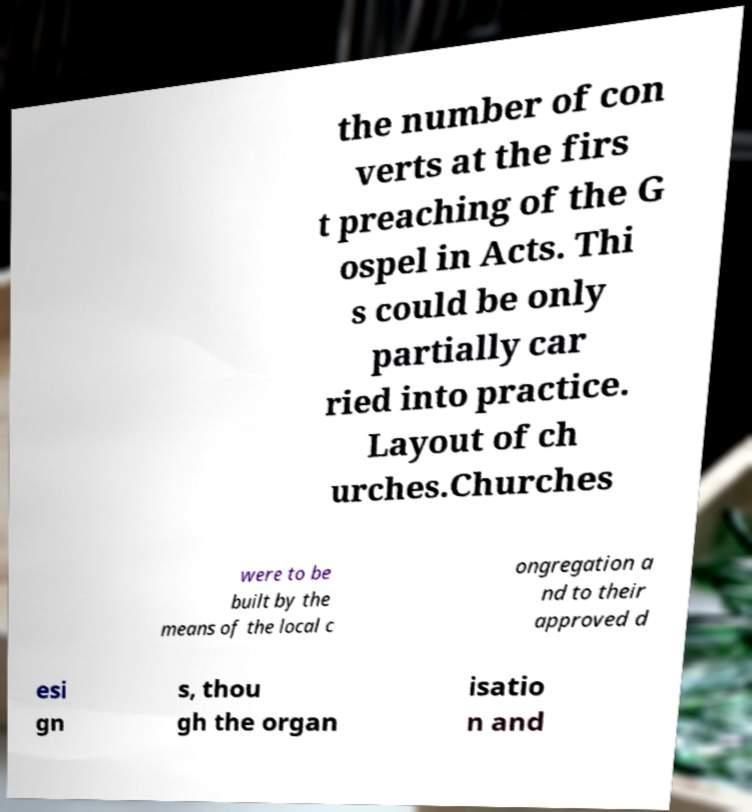For documentation purposes, I need the text within this image transcribed. Could you provide that? the number of con verts at the firs t preaching of the G ospel in Acts. Thi s could be only partially car ried into practice. Layout of ch urches.Churches were to be built by the means of the local c ongregation a nd to their approved d esi gn s, thou gh the organ isatio n and 